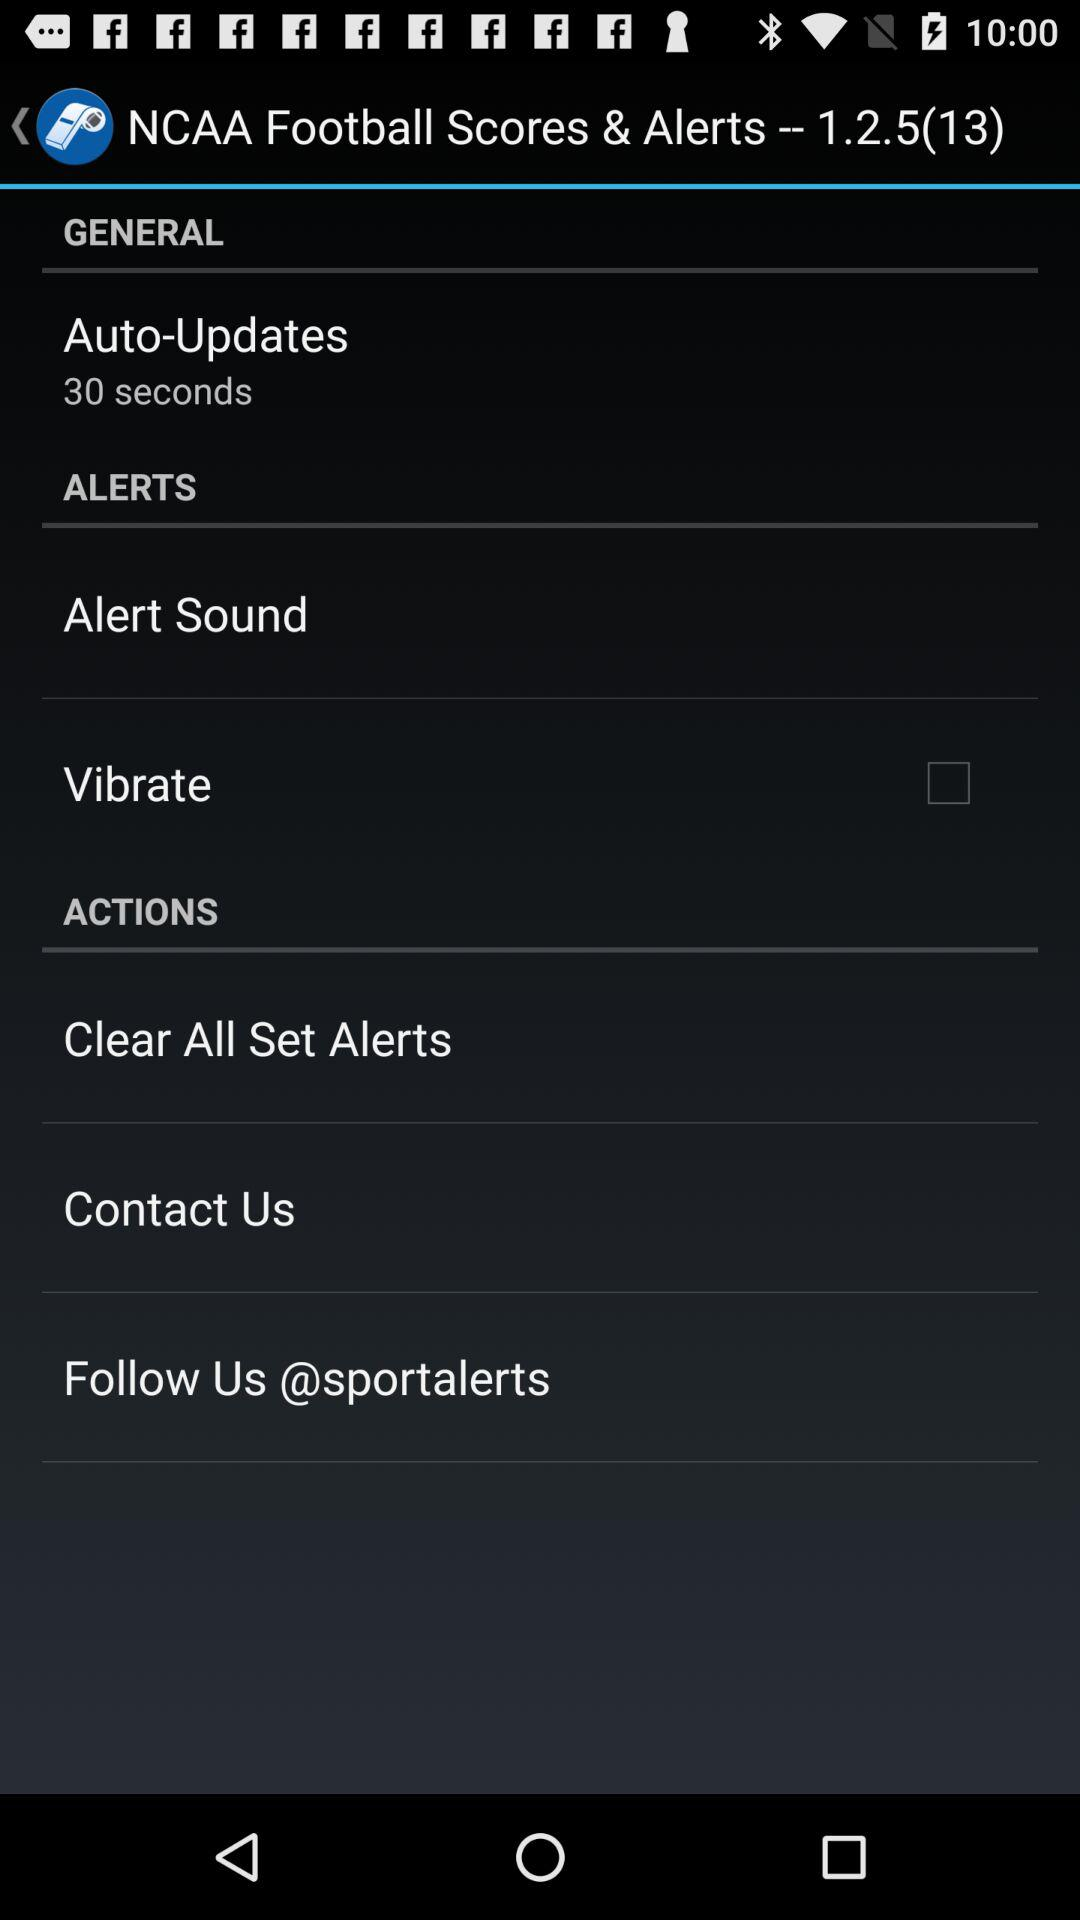How many items in the Actions section have a checkbox?
Answer the question using a single word or phrase. 1 